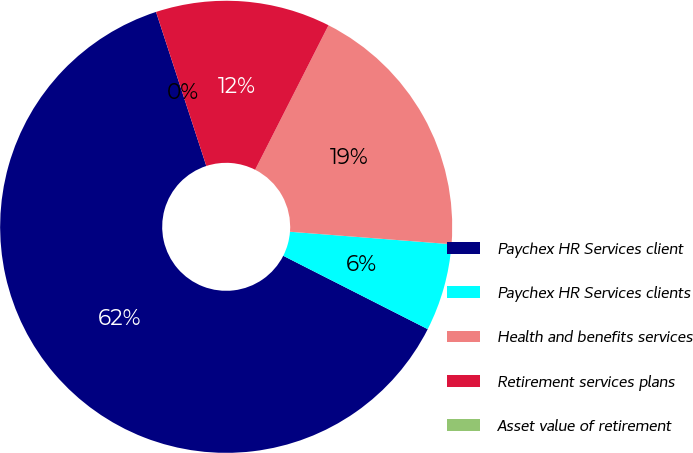Convert chart. <chart><loc_0><loc_0><loc_500><loc_500><pie_chart><fcel>Paychex HR Services client<fcel>Paychex HR Services clients<fcel>Health and benefits services<fcel>Retirement services plans<fcel>Asset value of retirement<nl><fcel>62.5%<fcel>6.25%<fcel>18.75%<fcel>12.5%<fcel>0.0%<nl></chart> 